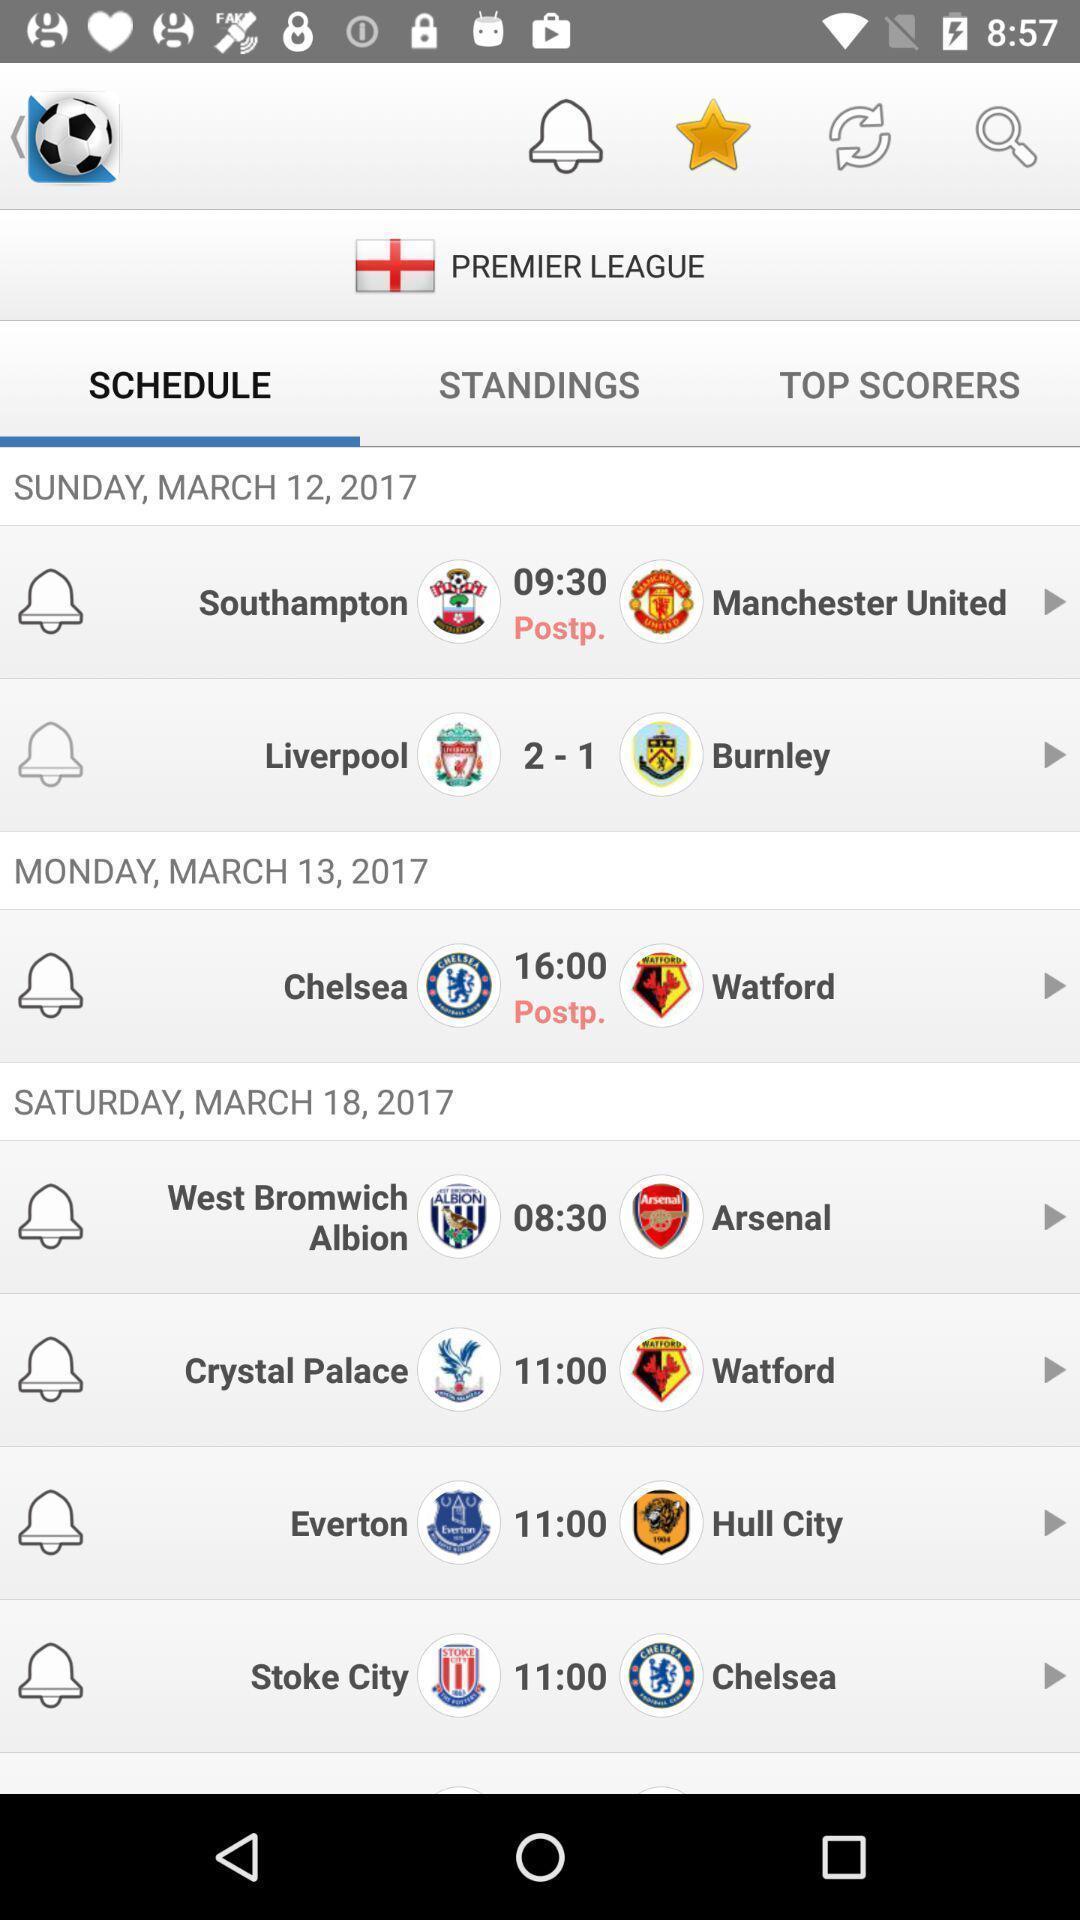Provide a detailed account of this screenshot. Sport app displayed different match schedules and other options. 